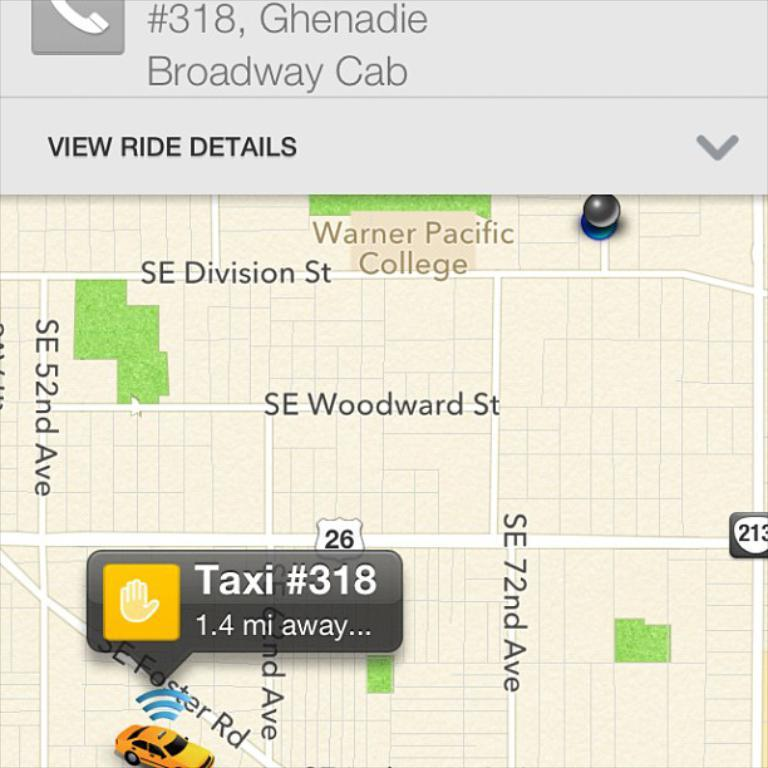Provide a one-sentence caption for the provided image. A taxi is 1.4 miles away on SE Faster Road. 